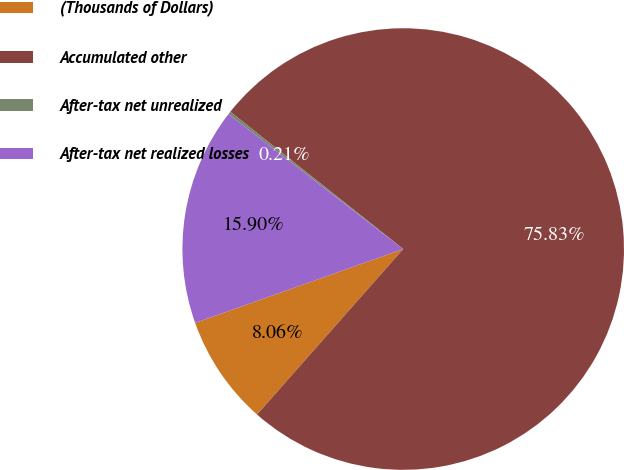Convert chart. <chart><loc_0><loc_0><loc_500><loc_500><pie_chart><fcel>(Thousands of Dollars)<fcel>Accumulated other<fcel>After-tax net unrealized<fcel>After-tax net realized losses<nl><fcel>8.06%<fcel>75.83%<fcel>0.21%<fcel>15.9%<nl></chart> 